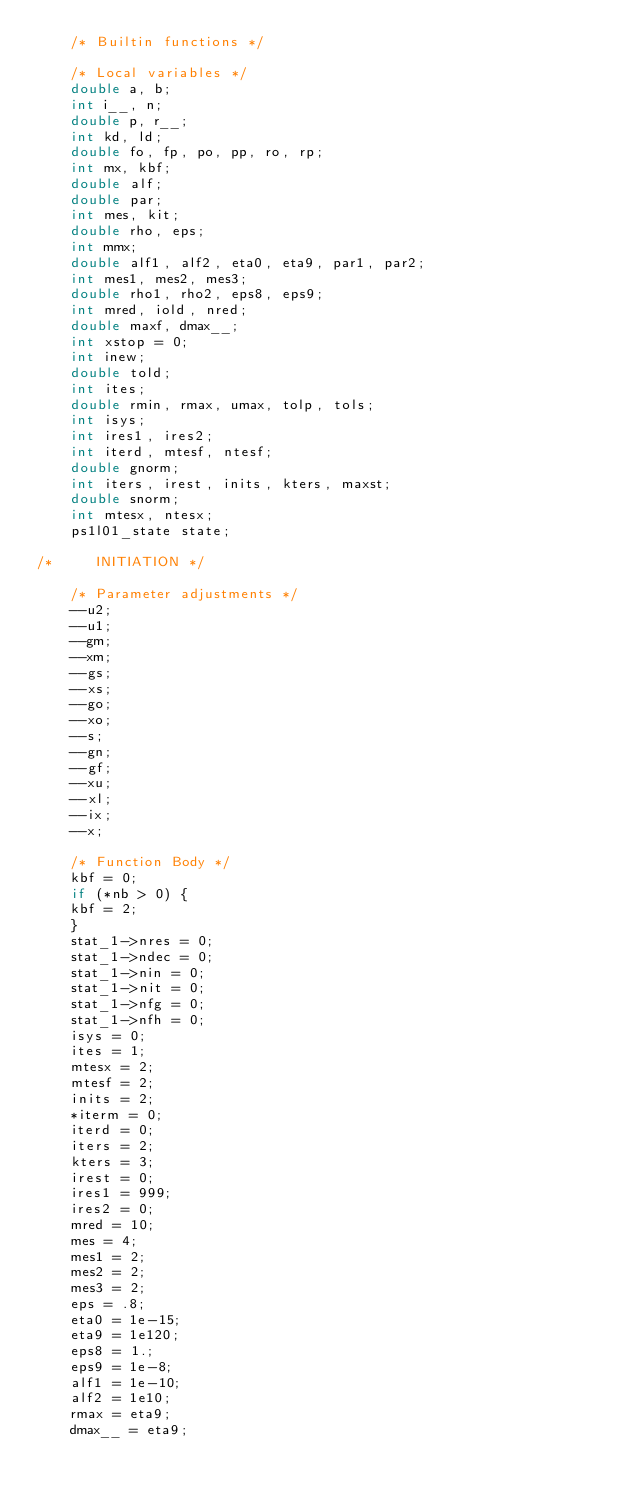Convert code to text. <code><loc_0><loc_0><loc_500><loc_500><_C++_>    /* Builtin functions */

    /* Local variables */
    double a, b;
    int i__, n;
    double p, r__;
    int kd, ld;
    double fo, fp, po, pp, ro, rp;
    int mx, kbf;
    double alf;
    double par;
    int mes, kit;
    double rho, eps;
    int mmx;
    double alf1, alf2, eta0, eta9, par1, par2;
    int mes1, mes2, mes3;
    double rho1, rho2, eps8, eps9;
    int mred, iold, nred;
    double maxf, dmax__;
    int xstop = 0;
    int inew;
    double told;
    int ites;
    double rmin, rmax, umax, tolp, tols;
    int isys;
    int ires1, ires2;
    int iterd, mtesf, ntesf;
    double gnorm;
    int iters, irest, inits, kters, maxst;
    double snorm;
    int mtesx, ntesx;
    ps1l01_state state;

/*     INITIATION */

    /* Parameter adjustments */
    --u2;
    --u1;
    --gm;
    --xm;
    --gs;
    --xs;
    --go;
    --xo;
    --s;
    --gn;
    --gf;
    --xu;
    --xl;
    --ix;
    --x;

    /* Function Body */
    kbf = 0;
    if (*nb > 0) {
	kbf = 2;
    }
    stat_1->nres = 0;
    stat_1->ndec = 0;
    stat_1->nin = 0;
    stat_1->nit = 0;
    stat_1->nfg = 0;
    stat_1->nfh = 0;
    isys = 0;
    ites = 1;
    mtesx = 2;
    mtesf = 2;
    inits = 2;
    *iterm = 0;
    iterd = 0;
    iters = 2;
    kters = 3;
    irest = 0;
    ires1 = 999;
    ires2 = 0;
    mred = 10;
    mes = 4;
    mes1 = 2;
    mes2 = 2;
    mes3 = 2;
    eps = .8;
    eta0 = 1e-15;
    eta9 = 1e120;
    eps8 = 1.;
    eps9 = 1e-8;
    alf1 = 1e-10;
    alf2 = 1e10;
    rmax = eta9;
    dmax__ = eta9;</code> 